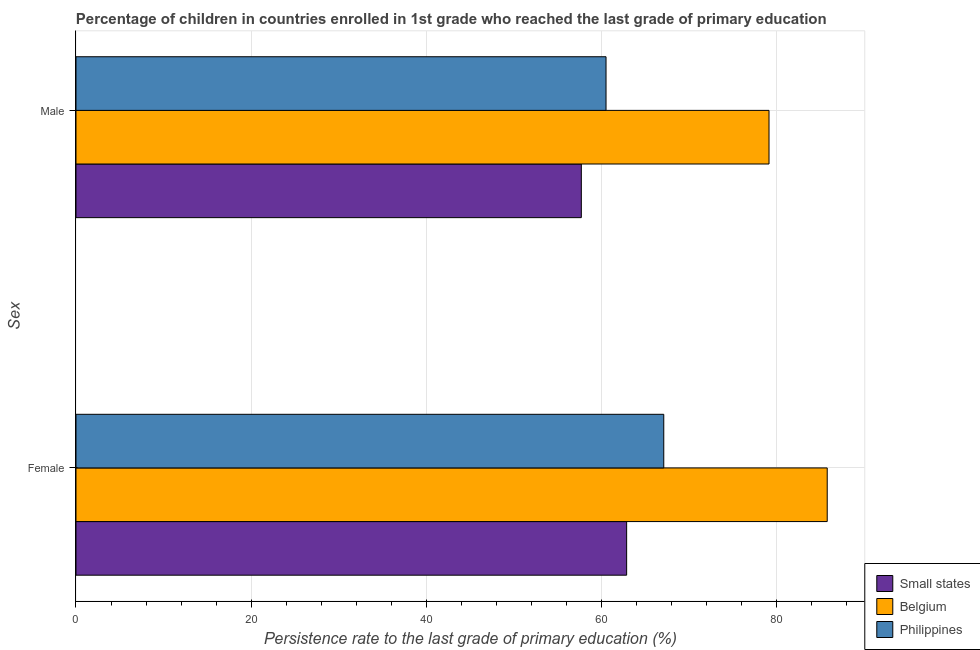Are the number of bars per tick equal to the number of legend labels?
Make the answer very short. Yes. How many bars are there on the 1st tick from the bottom?
Your response must be concise. 3. What is the persistence rate of female students in Belgium?
Keep it short and to the point. 85.75. Across all countries, what is the maximum persistence rate of female students?
Provide a succinct answer. 85.75. Across all countries, what is the minimum persistence rate of male students?
Provide a short and direct response. 57.68. In which country was the persistence rate of male students maximum?
Keep it short and to the point. Belgium. In which country was the persistence rate of female students minimum?
Your answer should be very brief. Small states. What is the total persistence rate of male students in the graph?
Provide a succinct answer. 197.29. What is the difference between the persistence rate of male students in Small states and that in Philippines?
Ensure brevity in your answer.  -2.82. What is the difference between the persistence rate of male students in Small states and the persistence rate of female students in Philippines?
Offer a terse response. -9.41. What is the average persistence rate of female students per country?
Provide a succinct answer. 71.9. What is the difference between the persistence rate of male students and persistence rate of female students in Philippines?
Your response must be concise. -6.59. What is the ratio of the persistence rate of female students in Philippines to that in Small states?
Keep it short and to the point. 1.07. What does the 1st bar from the top in Male represents?
Provide a succinct answer. Philippines. What does the 2nd bar from the bottom in Male represents?
Offer a terse response. Belgium. How many bars are there?
Your answer should be very brief. 6. Are all the bars in the graph horizontal?
Offer a terse response. Yes. How many countries are there in the graph?
Provide a short and direct response. 3. What is the difference between two consecutive major ticks on the X-axis?
Give a very brief answer. 20. Are the values on the major ticks of X-axis written in scientific E-notation?
Make the answer very short. No. What is the title of the graph?
Make the answer very short. Percentage of children in countries enrolled in 1st grade who reached the last grade of primary education. What is the label or title of the X-axis?
Provide a short and direct response. Persistence rate to the last grade of primary education (%). What is the label or title of the Y-axis?
Offer a terse response. Sex. What is the Persistence rate to the last grade of primary education (%) in Small states in Female?
Ensure brevity in your answer.  62.85. What is the Persistence rate to the last grade of primary education (%) of Belgium in Female?
Offer a very short reply. 85.75. What is the Persistence rate to the last grade of primary education (%) in Philippines in Female?
Keep it short and to the point. 67.09. What is the Persistence rate to the last grade of primary education (%) of Small states in Male?
Your answer should be compact. 57.68. What is the Persistence rate to the last grade of primary education (%) in Belgium in Male?
Your answer should be compact. 79.11. What is the Persistence rate to the last grade of primary education (%) of Philippines in Male?
Offer a very short reply. 60.5. Across all Sex, what is the maximum Persistence rate to the last grade of primary education (%) of Small states?
Offer a very short reply. 62.85. Across all Sex, what is the maximum Persistence rate to the last grade of primary education (%) of Belgium?
Provide a succinct answer. 85.75. Across all Sex, what is the maximum Persistence rate to the last grade of primary education (%) in Philippines?
Offer a very short reply. 67.09. Across all Sex, what is the minimum Persistence rate to the last grade of primary education (%) of Small states?
Provide a short and direct response. 57.68. Across all Sex, what is the minimum Persistence rate to the last grade of primary education (%) in Belgium?
Offer a terse response. 79.11. Across all Sex, what is the minimum Persistence rate to the last grade of primary education (%) of Philippines?
Your answer should be compact. 60.5. What is the total Persistence rate to the last grade of primary education (%) in Small states in the graph?
Offer a very short reply. 120.54. What is the total Persistence rate to the last grade of primary education (%) of Belgium in the graph?
Offer a terse response. 164.86. What is the total Persistence rate to the last grade of primary education (%) of Philippines in the graph?
Provide a succinct answer. 127.59. What is the difference between the Persistence rate to the last grade of primary education (%) of Small states in Female and that in Male?
Provide a short and direct response. 5.17. What is the difference between the Persistence rate to the last grade of primary education (%) of Belgium in Female and that in Male?
Offer a terse response. 6.64. What is the difference between the Persistence rate to the last grade of primary education (%) in Philippines in Female and that in Male?
Your answer should be very brief. 6.59. What is the difference between the Persistence rate to the last grade of primary education (%) of Small states in Female and the Persistence rate to the last grade of primary education (%) of Belgium in Male?
Ensure brevity in your answer.  -16.25. What is the difference between the Persistence rate to the last grade of primary education (%) of Small states in Female and the Persistence rate to the last grade of primary education (%) of Philippines in Male?
Offer a very short reply. 2.35. What is the difference between the Persistence rate to the last grade of primary education (%) in Belgium in Female and the Persistence rate to the last grade of primary education (%) in Philippines in Male?
Your answer should be very brief. 25.25. What is the average Persistence rate to the last grade of primary education (%) of Small states per Sex?
Your response must be concise. 60.27. What is the average Persistence rate to the last grade of primary education (%) of Belgium per Sex?
Provide a succinct answer. 82.43. What is the average Persistence rate to the last grade of primary education (%) of Philippines per Sex?
Provide a short and direct response. 63.8. What is the difference between the Persistence rate to the last grade of primary education (%) in Small states and Persistence rate to the last grade of primary education (%) in Belgium in Female?
Offer a terse response. -22.89. What is the difference between the Persistence rate to the last grade of primary education (%) in Small states and Persistence rate to the last grade of primary education (%) in Philippines in Female?
Ensure brevity in your answer.  -4.24. What is the difference between the Persistence rate to the last grade of primary education (%) in Belgium and Persistence rate to the last grade of primary education (%) in Philippines in Female?
Ensure brevity in your answer.  18.66. What is the difference between the Persistence rate to the last grade of primary education (%) of Small states and Persistence rate to the last grade of primary education (%) of Belgium in Male?
Keep it short and to the point. -21.42. What is the difference between the Persistence rate to the last grade of primary education (%) in Small states and Persistence rate to the last grade of primary education (%) in Philippines in Male?
Keep it short and to the point. -2.82. What is the difference between the Persistence rate to the last grade of primary education (%) in Belgium and Persistence rate to the last grade of primary education (%) in Philippines in Male?
Your answer should be very brief. 18.6. What is the ratio of the Persistence rate to the last grade of primary education (%) in Small states in Female to that in Male?
Your answer should be very brief. 1.09. What is the ratio of the Persistence rate to the last grade of primary education (%) of Belgium in Female to that in Male?
Your response must be concise. 1.08. What is the ratio of the Persistence rate to the last grade of primary education (%) of Philippines in Female to that in Male?
Provide a short and direct response. 1.11. What is the difference between the highest and the second highest Persistence rate to the last grade of primary education (%) in Small states?
Provide a short and direct response. 5.17. What is the difference between the highest and the second highest Persistence rate to the last grade of primary education (%) in Belgium?
Your answer should be compact. 6.64. What is the difference between the highest and the second highest Persistence rate to the last grade of primary education (%) in Philippines?
Your answer should be very brief. 6.59. What is the difference between the highest and the lowest Persistence rate to the last grade of primary education (%) of Small states?
Keep it short and to the point. 5.17. What is the difference between the highest and the lowest Persistence rate to the last grade of primary education (%) in Belgium?
Make the answer very short. 6.64. What is the difference between the highest and the lowest Persistence rate to the last grade of primary education (%) in Philippines?
Give a very brief answer. 6.59. 